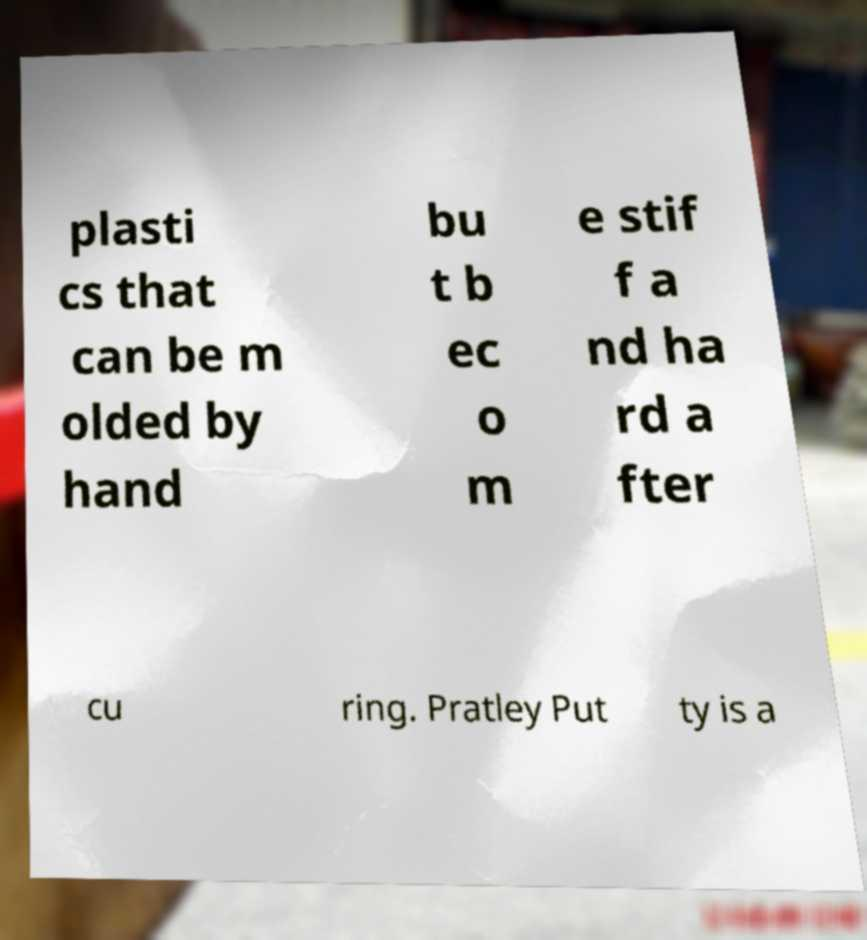What messages or text are displayed in this image? I need them in a readable, typed format. plasti cs that can be m olded by hand bu t b ec o m e stif f a nd ha rd a fter cu ring. Pratley Put ty is a 